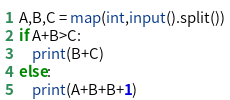<code> <loc_0><loc_0><loc_500><loc_500><_Python_>A,B,C = map(int,input().split())
if A+B>C:
    print(B+C)
else:
    print(A+B+B+1)</code> 